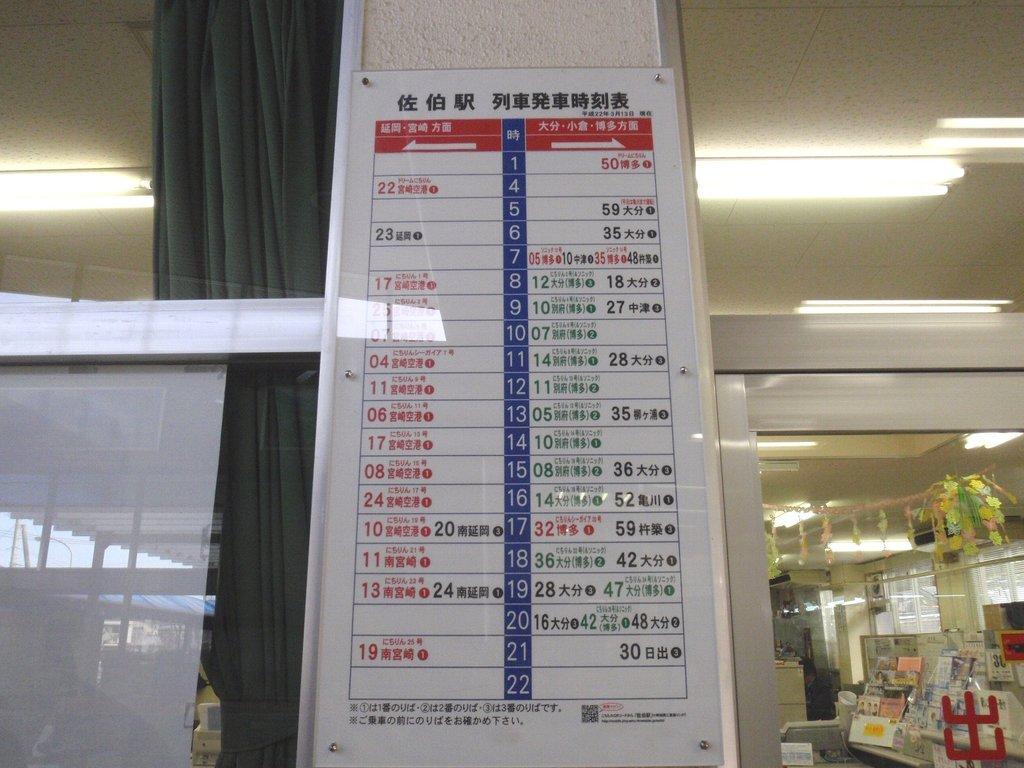In one or two sentences, can you explain what this image depicts? There is a white color hoarding which is attached to the wall near a glass window. In the background, there are lights attached to the roof, there are greeting cards arranged on the table, there is a curtain and there are other objects. 